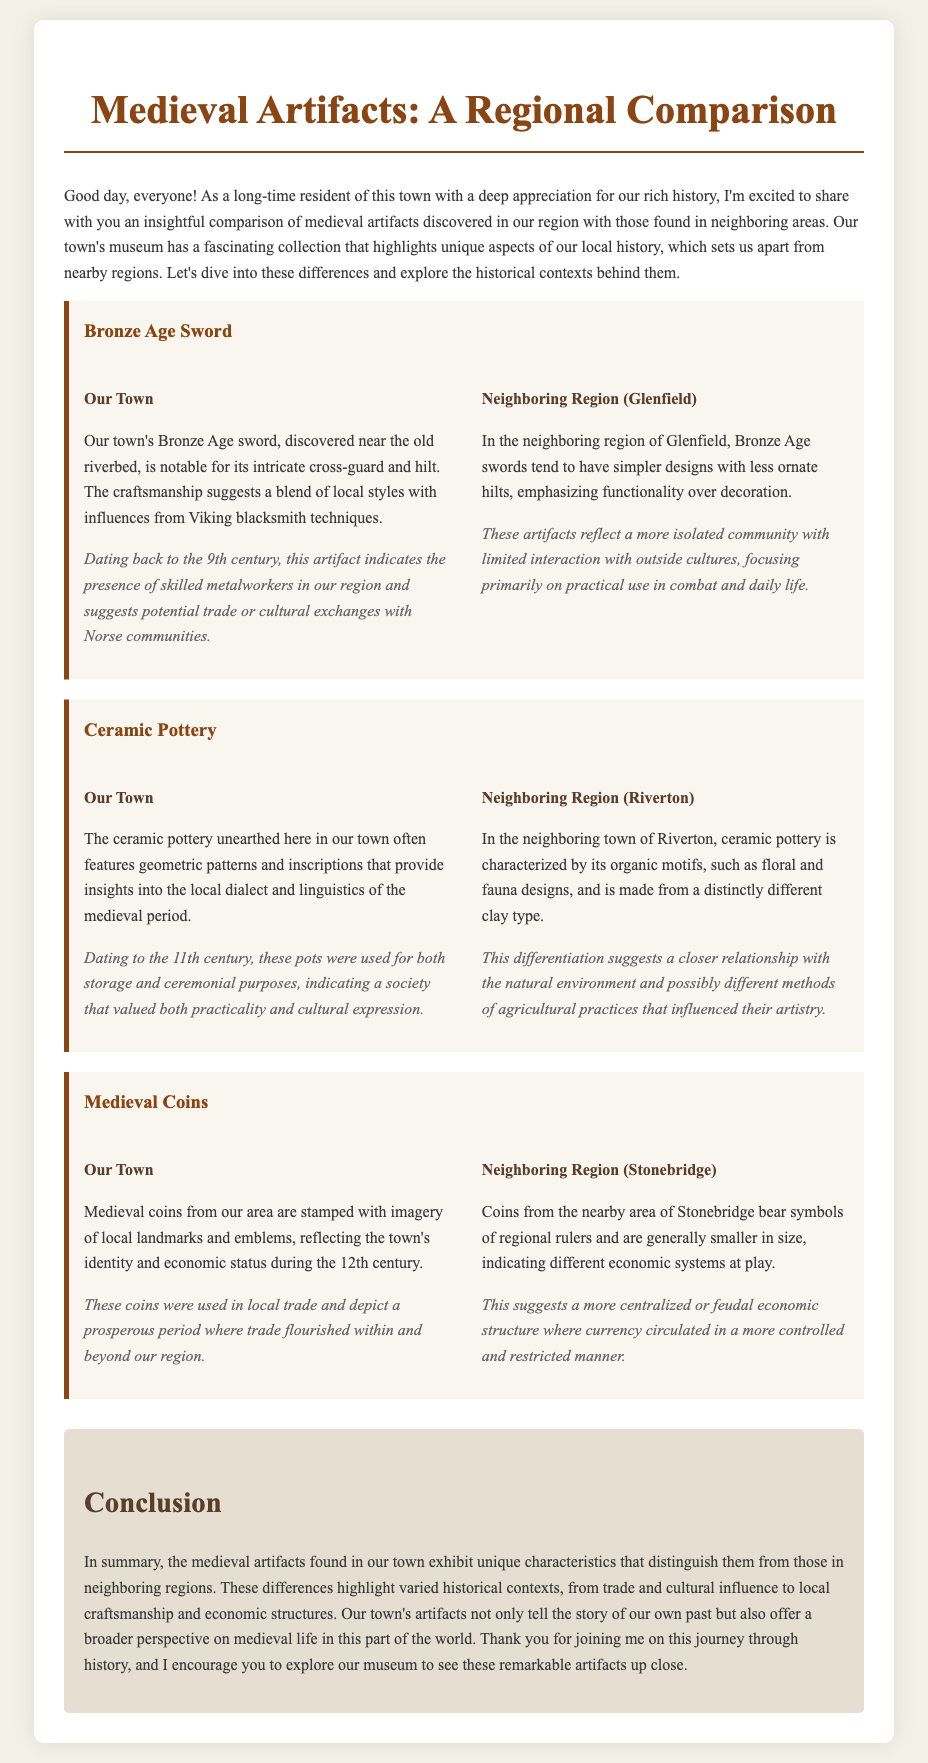what century does the Bronze Age sword date back to? The document states that the Bronze Age sword dates back to the 9th century.
Answer: 9th century what unique feature does the ceramic pottery in our town have? The ceramic pottery features geometric patterns and inscriptions that provide insights into the local dialect and linguistics of the medieval period.
Answer: geometric patterns and inscriptions how are the medieval coins from our town characterized? The medieval coins from our area are stamped with imagery of local landmarks and emblems.
Answer: local landmarks and emblems what is a significant difference between the swords from our town and Glenfield? The swords in our town have intricate designs, while those in Glenfield have simpler designs.
Answer: intricate vs. simpler designs what agricultural influence is suggested by the ceramic pottery in Riverton? The document suggests that the differing pottery designs indicate different agricultural practices that influenced their artistry.
Answer: different agricultural practices what period of prosperity do our town's medieval coins represent? These coins represent a prosperous period when trade flourished within and beyond our region during the 12th century.
Answer: 12th century what is the primary focus of the pottery found in Glenfield? The pottery in Glenfield emphasizes functionality over decoration, indicating a more practical approach.
Answer: functionality over decoration how does the historical context of our town's artifacts differ from Stonebridge's? The historical context of our town's artifacts is characterized by local trade and prosperity, while Stonebridge's coins indicate a more controlled economic structure.
Answer: local trade vs. controlled economic structure 